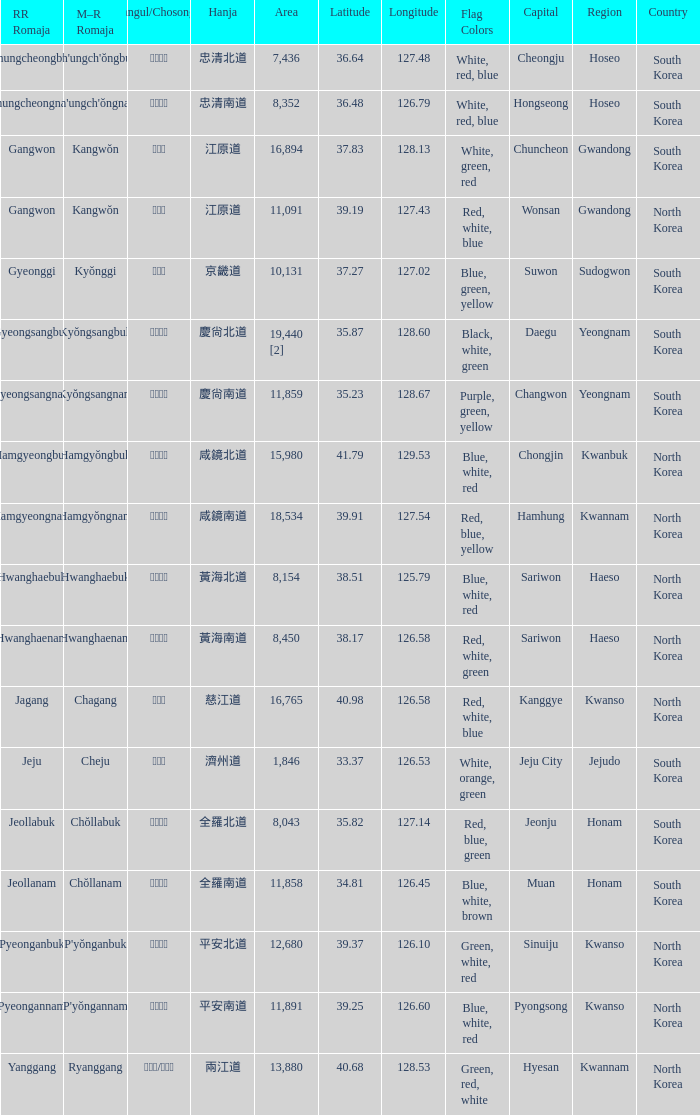Which country has a city with a Hanja of 平安北道? North Korea. Would you mind parsing the complete table? {'header': ['RR Romaja', 'M–R Romaja', 'Hangul/Chosongul', 'Hanja', 'Area', 'Latitude', 'Longitude', 'Flag Colors', 'Capital', 'Region', 'Country'], 'rows': [['Chungcheongbuk', "Ch'ungch'ŏngbuk", '충청북도', '忠清北道', '7,436', '36.64', '127.48', 'White, red, blue', 'Cheongju', 'Hoseo', 'South Korea'], ['Chungcheongnam', "Ch'ungch'ŏngnam", '충청남도', '忠清南道', '8,352', '36.48', '126.79', 'White, red, blue', 'Hongseong', 'Hoseo', 'South Korea'], ['Gangwon', 'Kangwŏn', '강원도', '江原道', '16,894', '37.83', '128.13', 'White, green, red', 'Chuncheon', 'Gwandong', 'South Korea'], ['Gangwon', 'Kangwŏn', '강원도', '江原道', '11,091', '39.19', '127.43', 'Red, white, blue', 'Wonsan', 'Gwandong', 'North Korea'], ['Gyeonggi', 'Kyŏnggi', '경기도', '京畿道', '10,131', '37.27', '127.02', 'Blue, green, yellow', 'Suwon', 'Sudogwon', 'South Korea'], ['Gyeongsangbuk', 'Kyŏngsangbuk', '경상북도', '慶尙北道', '19,440 [2]', '35.87', '128.60', 'Black, white, green', 'Daegu', 'Yeongnam', 'South Korea'], ['Gyeongsangnam', 'Kyŏngsangnam', '경상남도', '慶尙南道', '11,859', '35.23', '128.67', 'Purple, green, yellow', 'Changwon', 'Yeongnam', 'South Korea'], ['Hamgyeongbuk', 'Hamgyŏngbuk', '함경북도', '咸鏡北道', '15,980', '41.79', '129.53', 'Blue, white, red', 'Chongjin', 'Kwanbuk', 'North Korea'], ['Hamgyeongnam', 'Hamgyŏngnam', '함경남도', '咸鏡南道', '18,534', '39.91', '127.54', 'Red, blue, yellow', 'Hamhung', 'Kwannam', 'North Korea'], ['Hwanghaebuk', 'Hwanghaebuk', '황해북도', '黃海北道', '8,154', '38.51', '125.79', 'Blue, white, red', 'Sariwon', 'Haeso', 'North Korea'], ['Hwanghaenam', 'Hwanghaenam', '황해남도', '黃海南道', '8,450', '38.17', '126.58', 'Red, white, green', 'Sariwon', 'Haeso', 'North Korea'], ['Jagang', 'Chagang', '자강도', '慈江道', '16,765', '40.98', '126.58', 'Red, white, blue', 'Kanggye', 'Kwanso', 'North Korea'], ['Jeju', 'Cheju', '제주도', '濟州道', '1,846', '33.37', '126.53', 'White, orange, green', 'Jeju City', 'Jejudo', 'South Korea'], ['Jeollabuk', 'Chŏllabuk', '전라북도', '全羅北道', '8,043', '35.82', '127.14', 'Red, blue, green', 'Jeonju', 'Honam', 'South Korea'], ['Jeollanam', 'Chŏllanam', '전라남도', '全羅南道', '11,858', '34.81', '126.45', 'Blue, white, brown', 'Muan', 'Honam', 'South Korea'], ['Pyeonganbuk', "P'yŏnganbuk", '평안북도', '平安北道', '12,680', '39.37', '126.10', 'Green, white, red', 'Sinuiju', 'Kwanso', 'North Korea'], ['Pyeongannam', "P'yŏngannam", '평안남도', '平安南道', '11,891', '39.25', '126.60', 'Blue, white, red', 'Pyongsong', 'Kwanso', 'North Korea'], ['Yanggang', 'Ryanggang', '량강도/양강도', '兩江道', '13,880', '40.68', '128.53', 'Green, red, white', 'Hyesan', 'Kwannam', 'North Korea']]} 